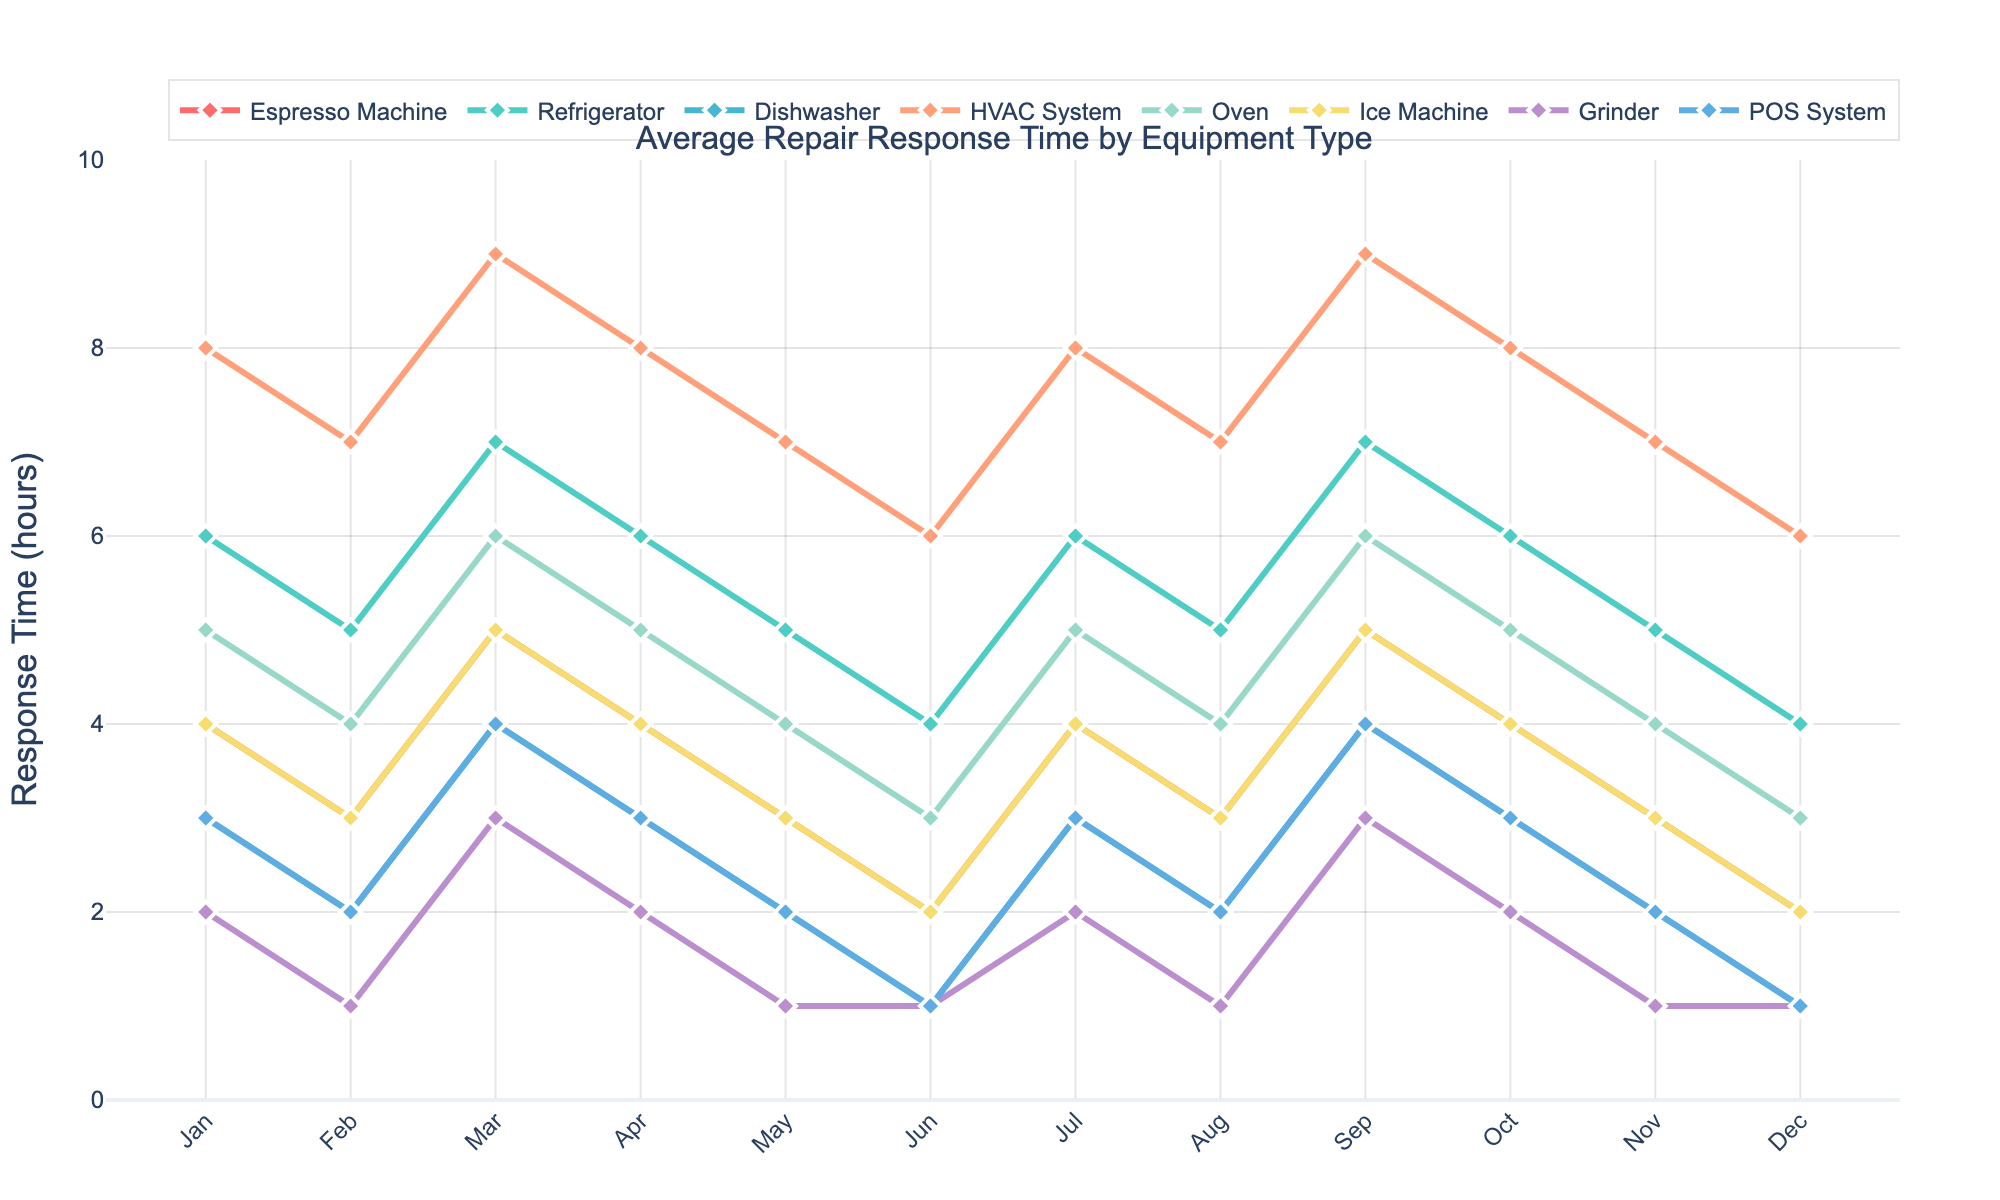what is the average repair response time for the Espresso Machine in the first quarter (Jan-Mar)? The first quarter includes January, February, and March. The response times for these months are 4, 3, and 5 hours, respectively. Sum these times: 4 + 3 + 5 = 12. Then, divide by the number of months: 12 / 3 = 4 hours.
Answer: 4 hours Which equipment type had the longest average repair response time in August? Look at the response times for all equipment types in August. The highest value is 7 hours for the HVAC System.
Answer: HVAC System Compare the repair response times for the Refrigerator and Oven in June. Which one is faster, and by how many hours? In June, the Refrigerator had a response time of 4 hours, and the Oven had a response time of 3 hours. The Refrigerator is slower by 4 - 3 = 1 hour.
Answer: Oven, 1 hour What is the difference in repair response time between the Dishwasher and Ice Machine in November? In November, the Dishwasher had a response time of 2 hours, and the Ice Machine had a response time of 3 hours. The difference is 3 - 2 = 1 hour.
Answer: 1 hour What is the trend in repair response time for the POS System from January to December? Observe the line for the POS System from January to December: 3, 2, 4, 3, 2, 1, 3, 2, 4, 3, 2, 1. The times decrease in certain months reaching a minimum in June and December.
Answer: Decreasing Which equipment type had the most consistent repair response time throughout the year, and what was the maximum variation in its response time? Look for the equipment with the smallest variations in response time. The Grinder had values of 2, 1, 3, 2, 1, 1, 2, 1, 3, 2, 1, 1. The maximum variation is 3 - 1 = 2 hours.
Answer: Grinder, 2 hours Between which two consecutive months did the Espresso Machine see the greatest increase in repair response time? Look at the differences between consecutive months for the Espresso Machine: 4-3=1, 5-3=2, 4-5=-1, 3-4=-1, 2-3=-1, 4-2=2, 3-4=-1, 5-3=2, 4-5=-1, 3-4=-1, 2-3=-1. The greatest increase is from February to March with an increase of 2 hours.
Answer: Feb to Mar, 2 hours What's the average repair response time across all equipment types in April? Add the response times for all equipment types in April and divide by the number of equipment types: (4+6+3+8+5+4+2+3) / 8 = 35 / 8 ≈ 4.375 hours.
Answer: 4.375 hours 